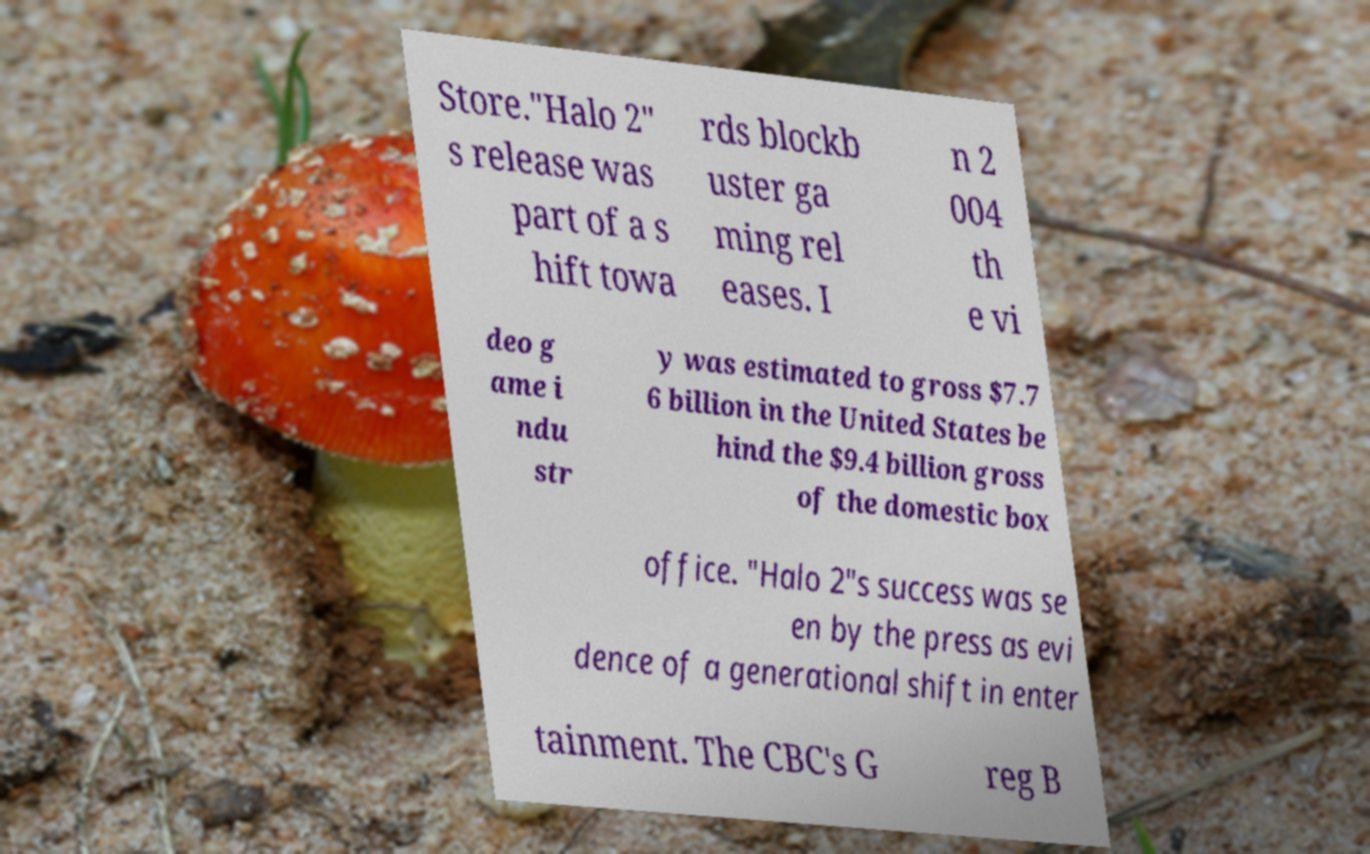Could you extract and type out the text from this image? Store."Halo 2" s release was part of a s hift towa rds blockb uster ga ming rel eases. I n 2 004 th e vi deo g ame i ndu str y was estimated to gross $7.7 6 billion in the United States be hind the $9.4 billion gross of the domestic box office. "Halo 2"s success was se en by the press as evi dence of a generational shift in enter tainment. The CBC's G reg B 